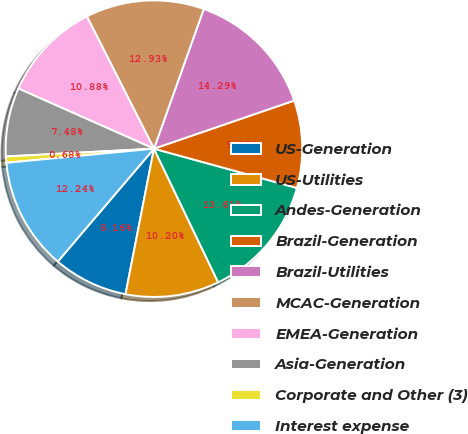Convert chart. <chart><loc_0><loc_0><loc_500><loc_500><pie_chart><fcel>US-Generation<fcel>US-Utilities<fcel>Andes-Generation<fcel>Brazil-Generation<fcel>Brazil-Utilities<fcel>MCAC-Generation<fcel>EMEA-Generation<fcel>Asia-Generation<fcel>Corporate and Other (3)<fcel>Interest expense<nl><fcel>8.16%<fcel>10.2%<fcel>13.6%<fcel>9.52%<fcel>14.28%<fcel>12.92%<fcel>10.88%<fcel>7.48%<fcel>0.68%<fcel>12.24%<nl></chart> 